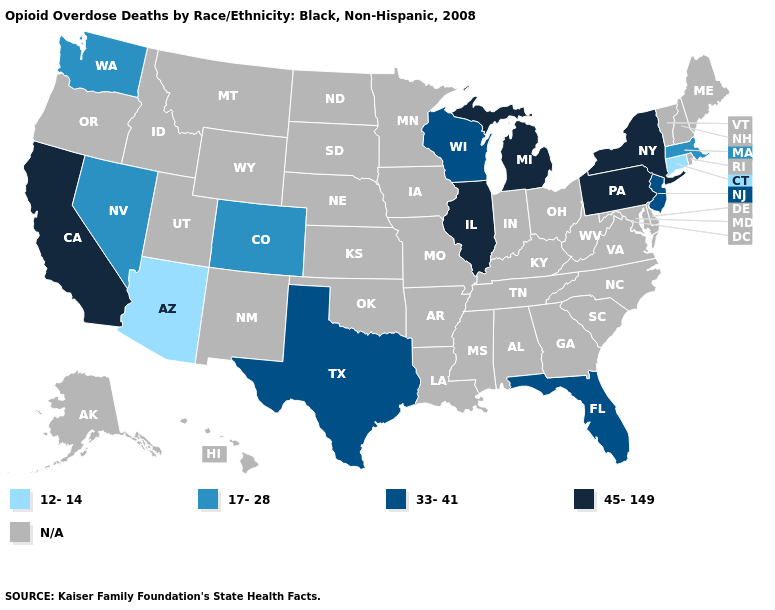Name the states that have a value in the range N/A?
Be succinct. Alabama, Alaska, Arkansas, Delaware, Georgia, Hawaii, Idaho, Indiana, Iowa, Kansas, Kentucky, Louisiana, Maine, Maryland, Minnesota, Mississippi, Missouri, Montana, Nebraska, New Hampshire, New Mexico, North Carolina, North Dakota, Ohio, Oklahoma, Oregon, Rhode Island, South Carolina, South Dakota, Tennessee, Utah, Vermont, Virginia, West Virginia, Wyoming. What is the value of New Jersey?
Give a very brief answer. 33-41. What is the value of South Carolina?
Give a very brief answer. N/A. Does Pennsylvania have the lowest value in the Northeast?
Quick response, please. No. What is the highest value in states that border Pennsylvania?
Write a very short answer. 45-149. What is the value of Nevada?
Be succinct. 17-28. Name the states that have a value in the range 45-149?
Keep it brief. California, Illinois, Michigan, New York, Pennsylvania. What is the lowest value in the USA?
Give a very brief answer. 12-14. What is the value of North Carolina?
Give a very brief answer. N/A. Does the map have missing data?
Be succinct. Yes. Name the states that have a value in the range 12-14?
Concise answer only. Arizona, Connecticut. What is the lowest value in the MidWest?
Quick response, please. 33-41. Name the states that have a value in the range 33-41?
Concise answer only. Florida, New Jersey, Texas, Wisconsin. 